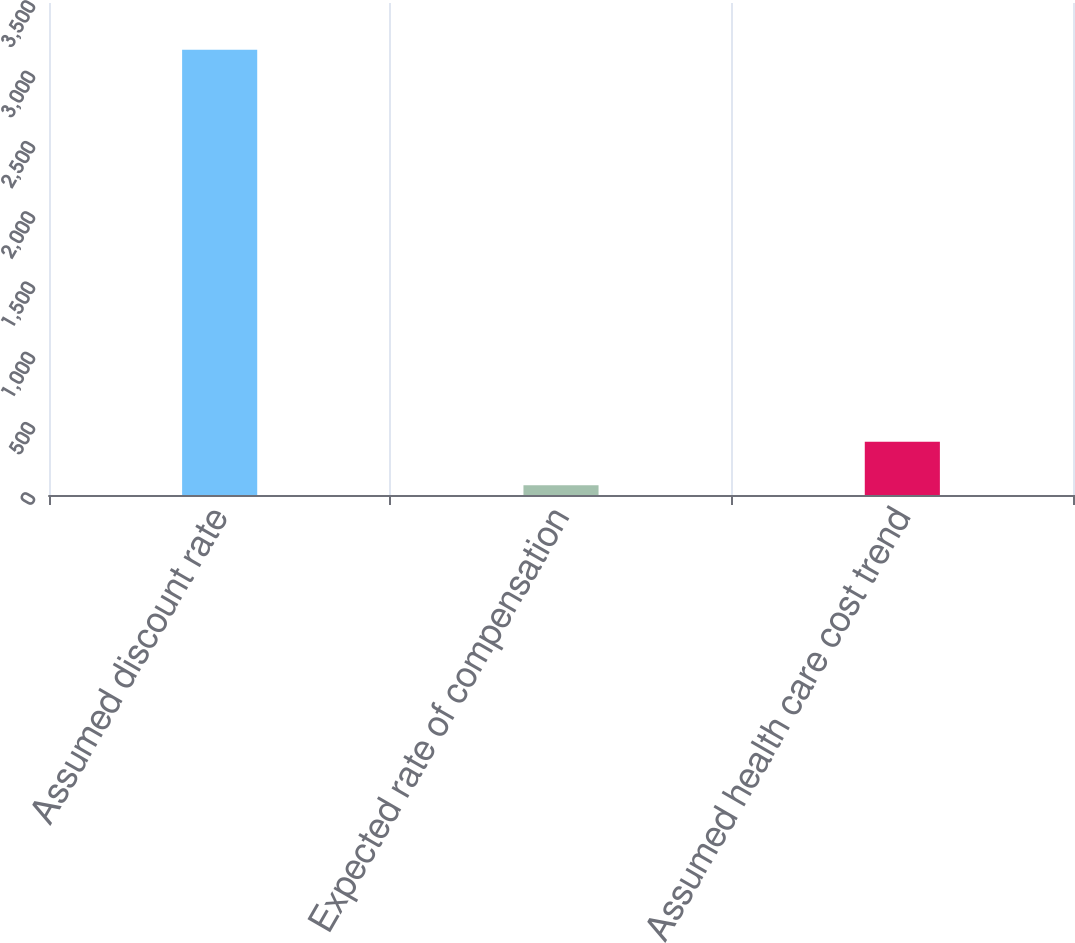<chart> <loc_0><loc_0><loc_500><loc_500><bar_chart><fcel>Assumed discount rate<fcel>Expected rate of compensation<fcel>Assumed health care cost trend<nl><fcel>3167<fcel>70<fcel>379.7<nl></chart> 